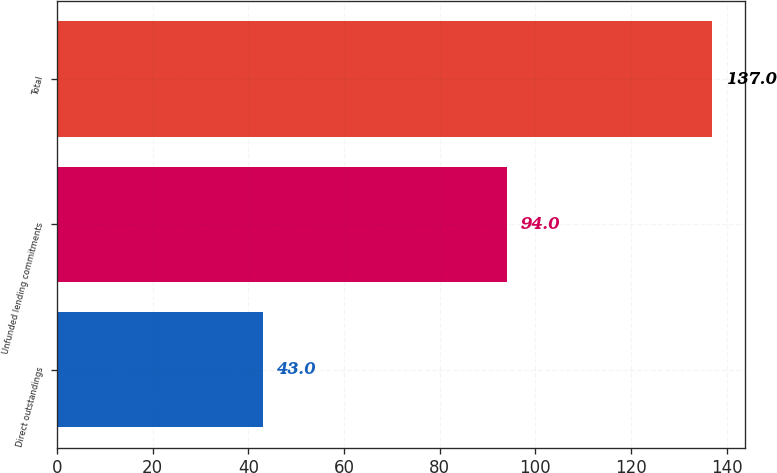Convert chart to OTSL. <chart><loc_0><loc_0><loc_500><loc_500><bar_chart><fcel>Direct outstandings<fcel>Unfunded lending commitments<fcel>Total<nl><fcel>43<fcel>94<fcel>137<nl></chart> 